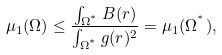<formula> <loc_0><loc_0><loc_500><loc_500>\mu _ { 1 } ( \Omega ) \leq \frac { \int _ { \Omega ^ { ^ { * } } } B ( r ) } { \int _ { \Omega ^ { ^ { * } } } g ( r ) ^ { 2 } } = \mu _ { 1 } ( \Omega ^ { ^ { * } } ) ,</formula> 